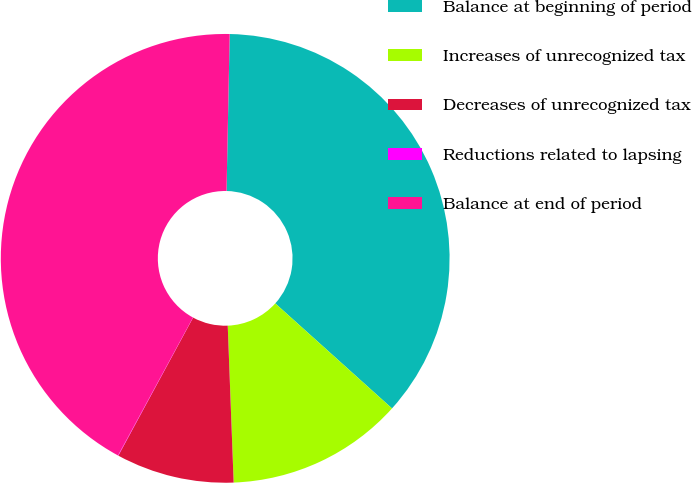Convert chart. <chart><loc_0><loc_0><loc_500><loc_500><pie_chart><fcel>Balance at beginning of period<fcel>Increases of unrecognized tax<fcel>Decreases of unrecognized tax<fcel>Reductions related to lapsing<fcel>Balance at end of period<nl><fcel>36.34%<fcel>12.74%<fcel>8.5%<fcel>0.03%<fcel>42.39%<nl></chart> 